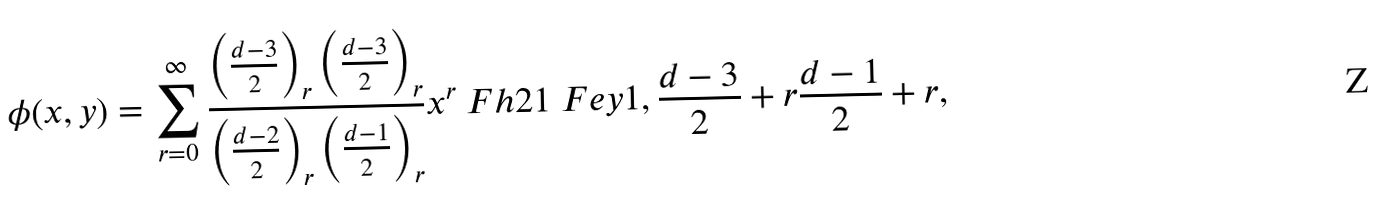Convert formula to latex. <formula><loc_0><loc_0><loc_500><loc_500>\phi ( x , y ) = \sum _ { r = 0 } ^ { \infty } \frac { \left ( \frac { d - 3 } { 2 } \right ) _ { r } \left ( \frac { d - 3 } { 2 } \right ) _ { r } } { \left ( \frac { d - 2 } { 2 } \right ) _ { r } \left ( \frac { d - 1 } { 2 } \right ) _ { r } } x ^ { r } \ F h 2 1 \ F e y { 1 , \frac { d - 3 } { 2 } + r } { \frac { d - 1 } { 2 } + r } ,</formula> 